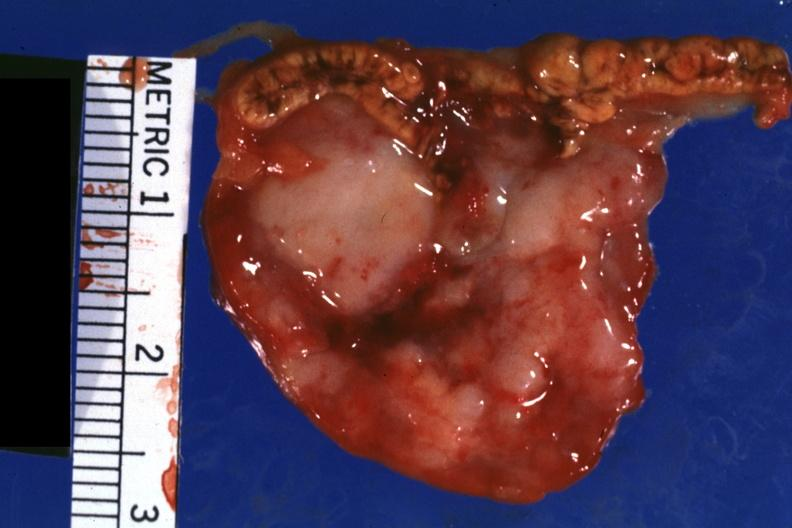s notochord shown well?
Answer the question using a single word or phrase. No 